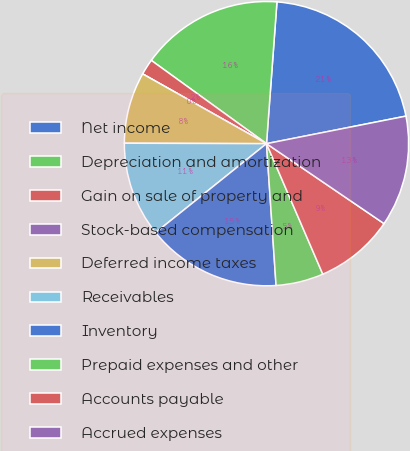Convert chart to OTSL. <chart><loc_0><loc_0><loc_500><loc_500><pie_chart><fcel>Net income<fcel>Depreciation and amortization<fcel>Gain on sale of property and<fcel>Stock-based compensation<fcel>Deferred income taxes<fcel>Receivables<fcel>Inventory<fcel>Prepaid expenses and other<fcel>Accounts payable<fcel>Accrued expenses<nl><fcel>20.72%<fcel>16.21%<fcel>1.8%<fcel>0.0%<fcel>8.11%<fcel>10.81%<fcel>15.31%<fcel>5.41%<fcel>9.01%<fcel>12.61%<nl></chart> 